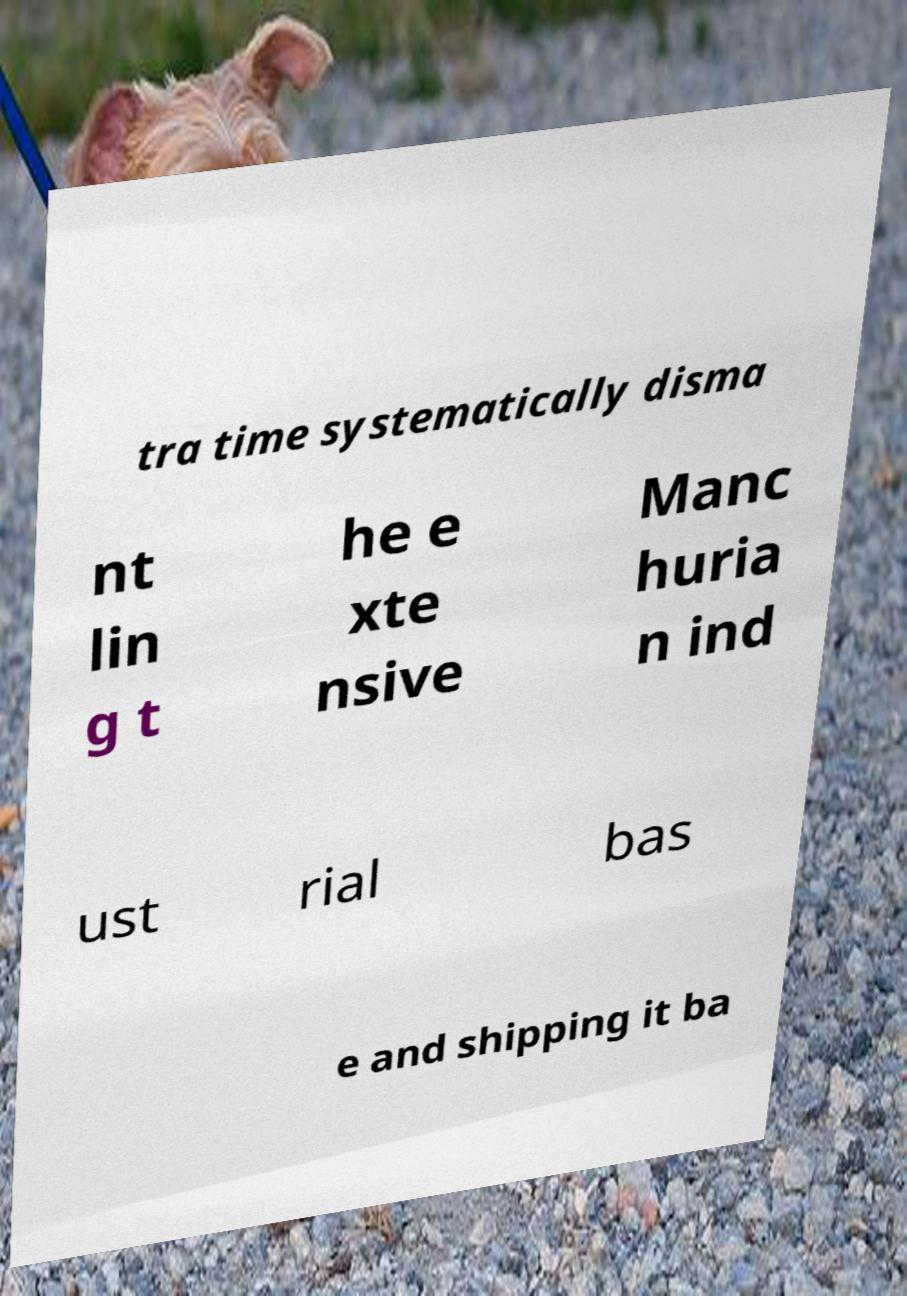Could you assist in decoding the text presented in this image and type it out clearly? tra time systematically disma nt lin g t he e xte nsive Manc huria n ind ust rial bas e and shipping it ba 